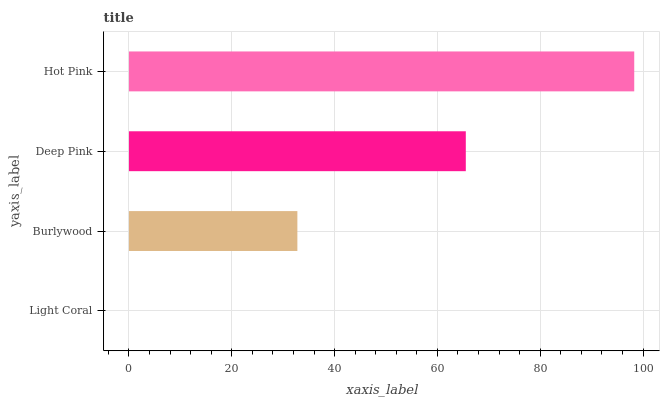Is Light Coral the minimum?
Answer yes or no. Yes. Is Hot Pink the maximum?
Answer yes or no. Yes. Is Burlywood the minimum?
Answer yes or no. No. Is Burlywood the maximum?
Answer yes or no. No. Is Burlywood greater than Light Coral?
Answer yes or no. Yes. Is Light Coral less than Burlywood?
Answer yes or no. Yes. Is Light Coral greater than Burlywood?
Answer yes or no. No. Is Burlywood less than Light Coral?
Answer yes or no. No. Is Deep Pink the high median?
Answer yes or no. Yes. Is Burlywood the low median?
Answer yes or no. Yes. Is Burlywood the high median?
Answer yes or no. No. Is Hot Pink the low median?
Answer yes or no. No. 